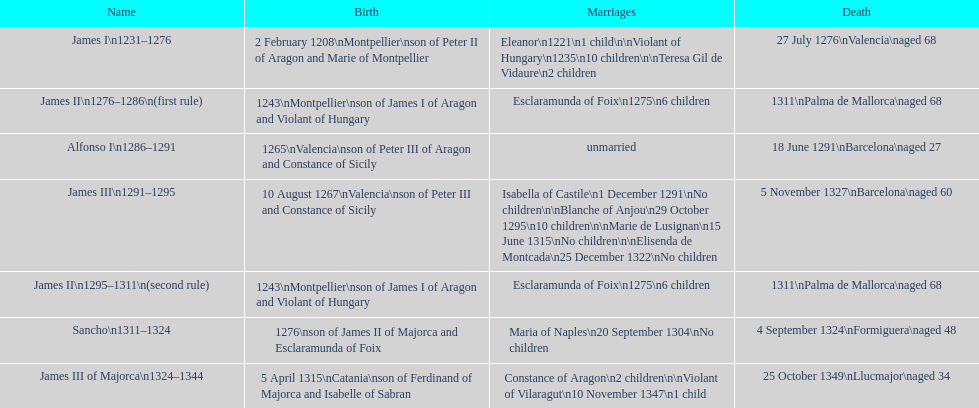Which two rulers had no offspring? Alfonso I, Sancho. 